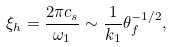<formula> <loc_0><loc_0><loc_500><loc_500>\xi _ { h } = \frac { 2 \pi c _ { s } } { \omega _ { 1 } } \sim \frac { 1 } { k _ { 1 } } \theta _ { f } ^ { - 1 / 2 } ,</formula> 